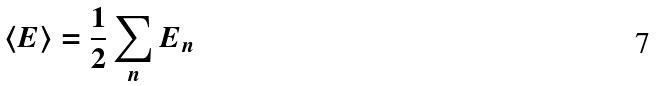Convert formula to latex. <formula><loc_0><loc_0><loc_500><loc_500>\langle E \rangle = \frac { 1 } { 2 } \sum _ { n } E _ { n }</formula> 